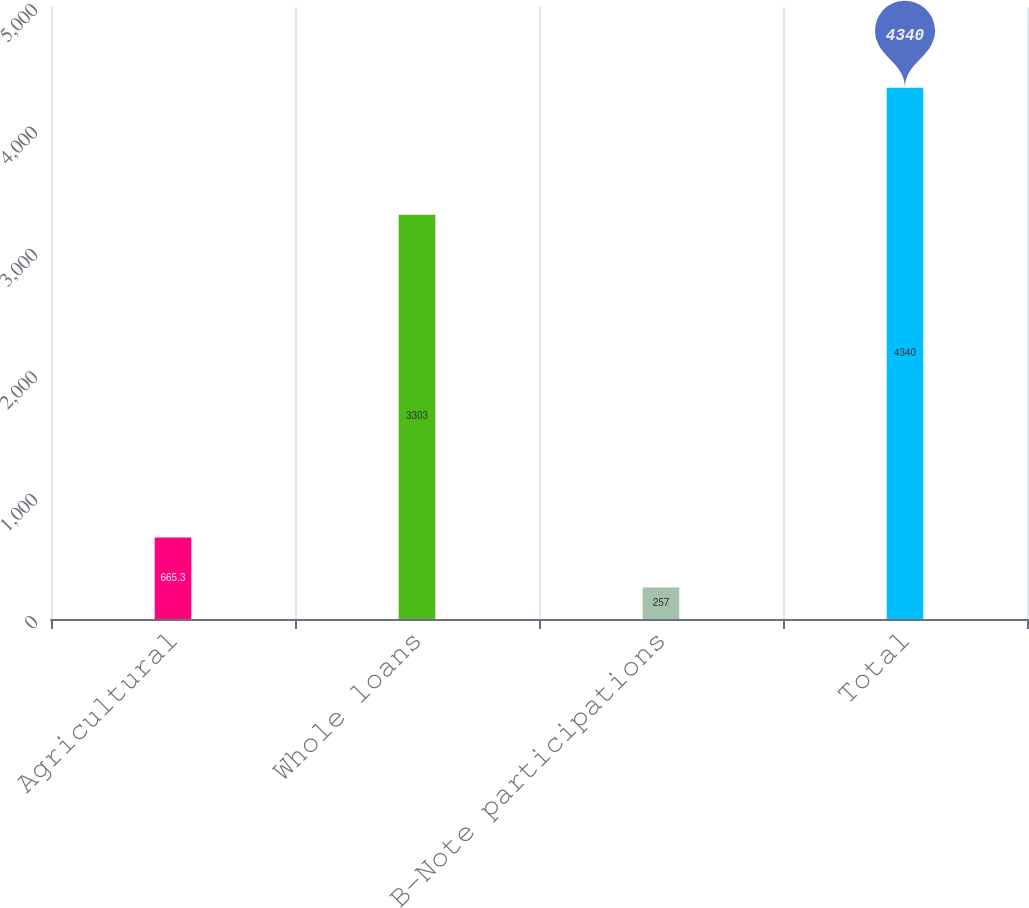Convert chart to OTSL. <chart><loc_0><loc_0><loc_500><loc_500><bar_chart><fcel>Agricultural<fcel>Whole loans<fcel>B-Note participations<fcel>Total<nl><fcel>665.3<fcel>3303<fcel>257<fcel>4340<nl></chart> 